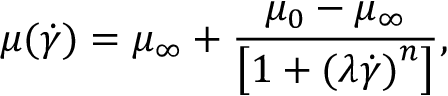Convert formula to latex. <formula><loc_0><loc_0><loc_500><loc_500>\mu ( \dot { \gamma } ) = \mu _ { \infty } + \frac { \mu _ { 0 } - \mu _ { \infty } } { { \left [ 1 + { ( \lambda \dot { \gamma } ) } ^ { n } \right ] } } ,</formula> 